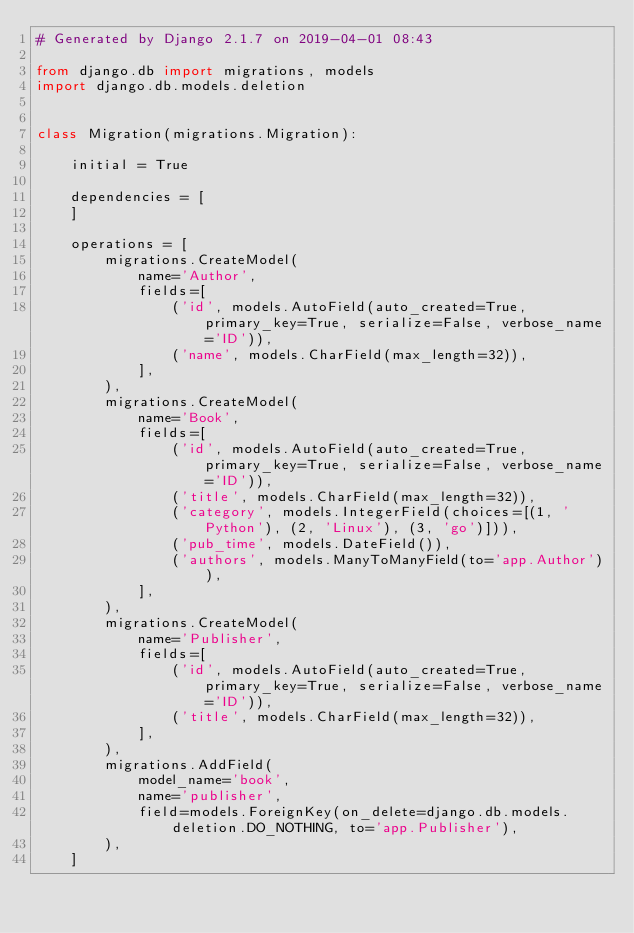Convert code to text. <code><loc_0><loc_0><loc_500><loc_500><_Python_># Generated by Django 2.1.7 on 2019-04-01 08:43

from django.db import migrations, models
import django.db.models.deletion


class Migration(migrations.Migration):

    initial = True

    dependencies = [
    ]

    operations = [
        migrations.CreateModel(
            name='Author',
            fields=[
                ('id', models.AutoField(auto_created=True, primary_key=True, serialize=False, verbose_name='ID')),
                ('name', models.CharField(max_length=32)),
            ],
        ),
        migrations.CreateModel(
            name='Book',
            fields=[
                ('id', models.AutoField(auto_created=True, primary_key=True, serialize=False, verbose_name='ID')),
                ('title', models.CharField(max_length=32)),
                ('category', models.IntegerField(choices=[(1, 'Python'), (2, 'Linux'), (3, 'go')])),
                ('pub_time', models.DateField()),
                ('authors', models.ManyToManyField(to='app.Author')),
            ],
        ),
        migrations.CreateModel(
            name='Publisher',
            fields=[
                ('id', models.AutoField(auto_created=True, primary_key=True, serialize=False, verbose_name='ID')),
                ('title', models.CharField(max_length=32)),
            ],
        ),
        migrations.AddField(
            model_name='book',
            name='publisher',
            field=models.ForeignKey(on_delete=django.db.models.deletion.DO_NOTHING, to='app.Publisher'),
        ),
    ]
</code> 